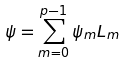<formula> <loc_0><loc_0><loc_500><loc_500>\psi = \sum _ { m = 0 } ^ { p - 1 } \psi _ { m } L _ { m }</formula> 